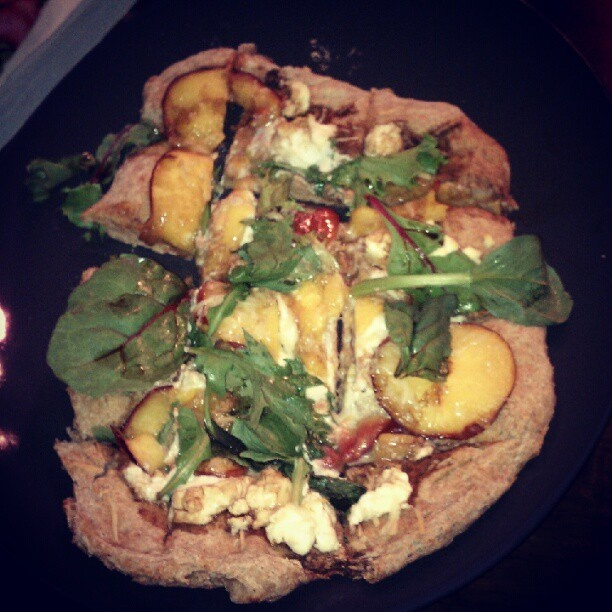Describe the objects in this image and their specific colors. I can see a pizza in black, brown, gray, and tan tones in this image. 